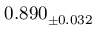<formula> <loc_0><loc_0><loc_500><loc_500>0 . 8 9 0 _ { \pm 0 . 0 3 2 }</formula> 